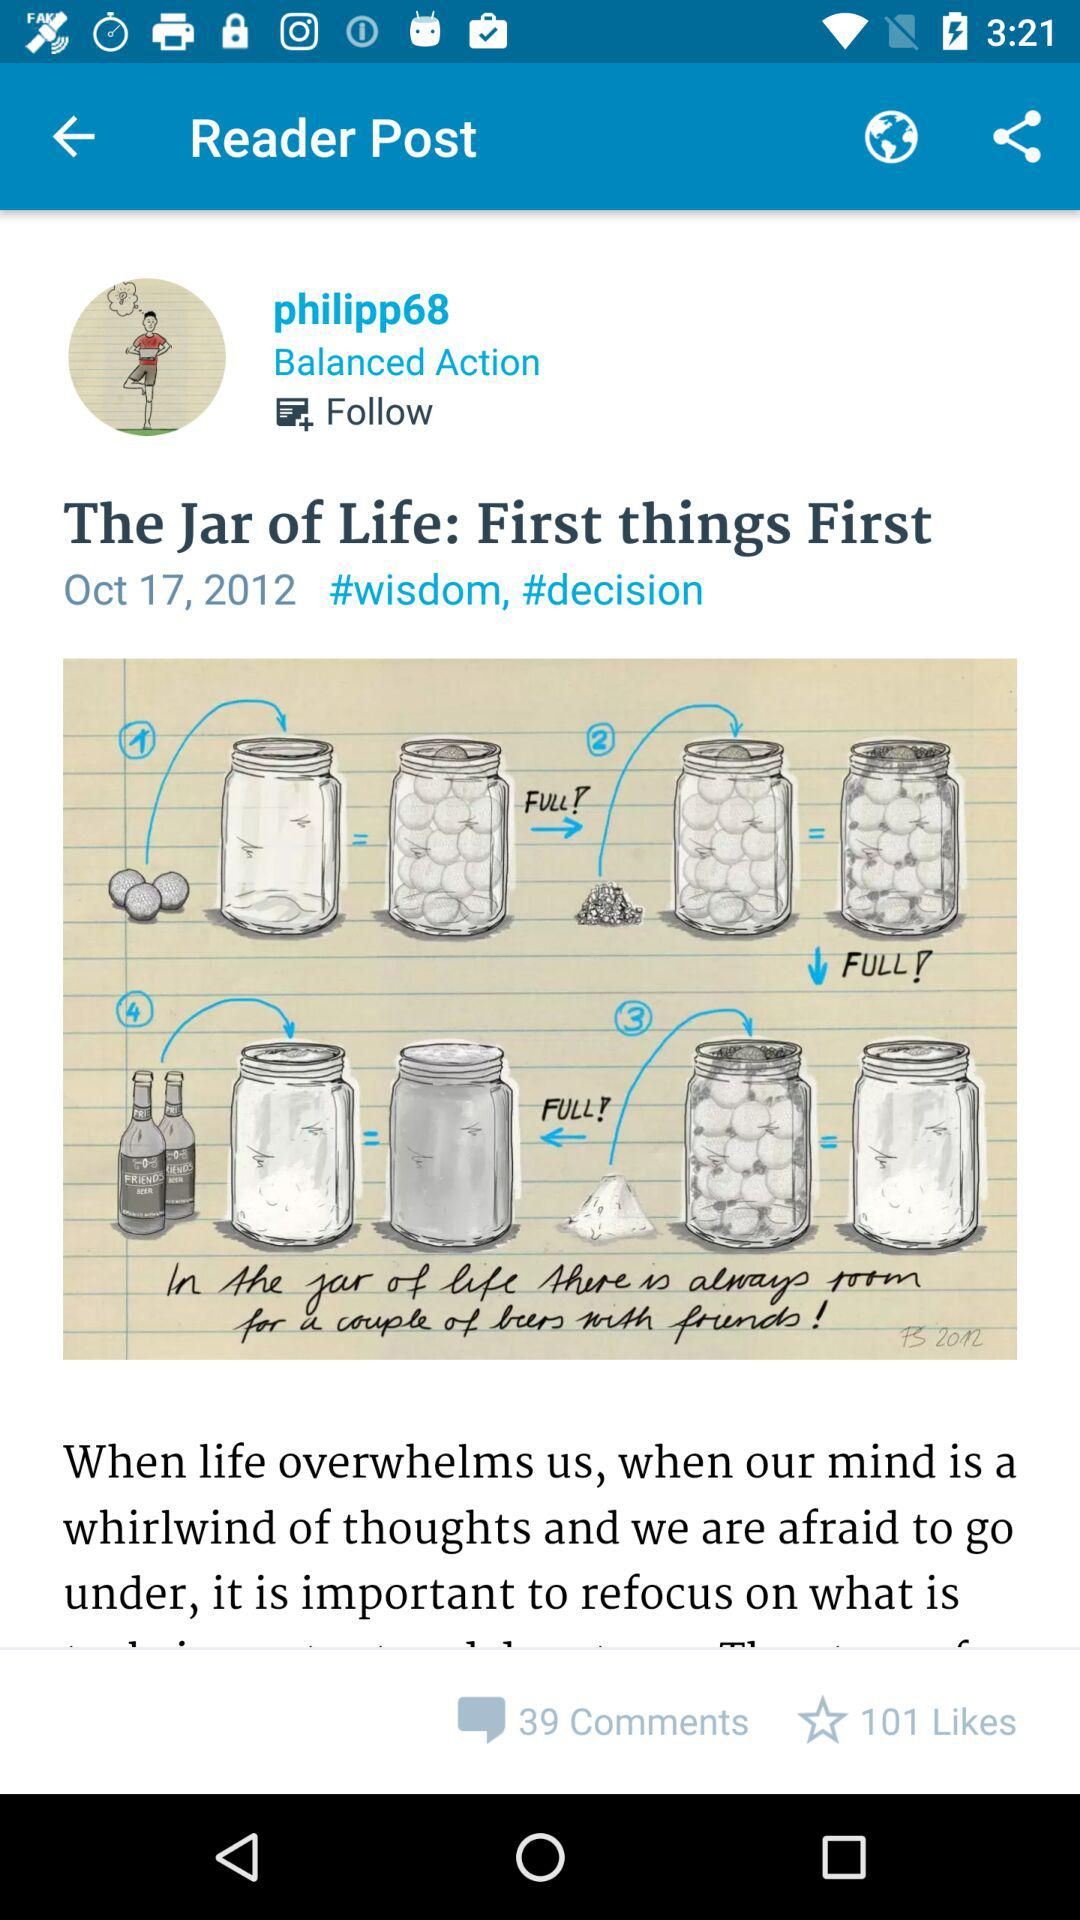When was the post posted? The post was posted on October 17, 2012. 